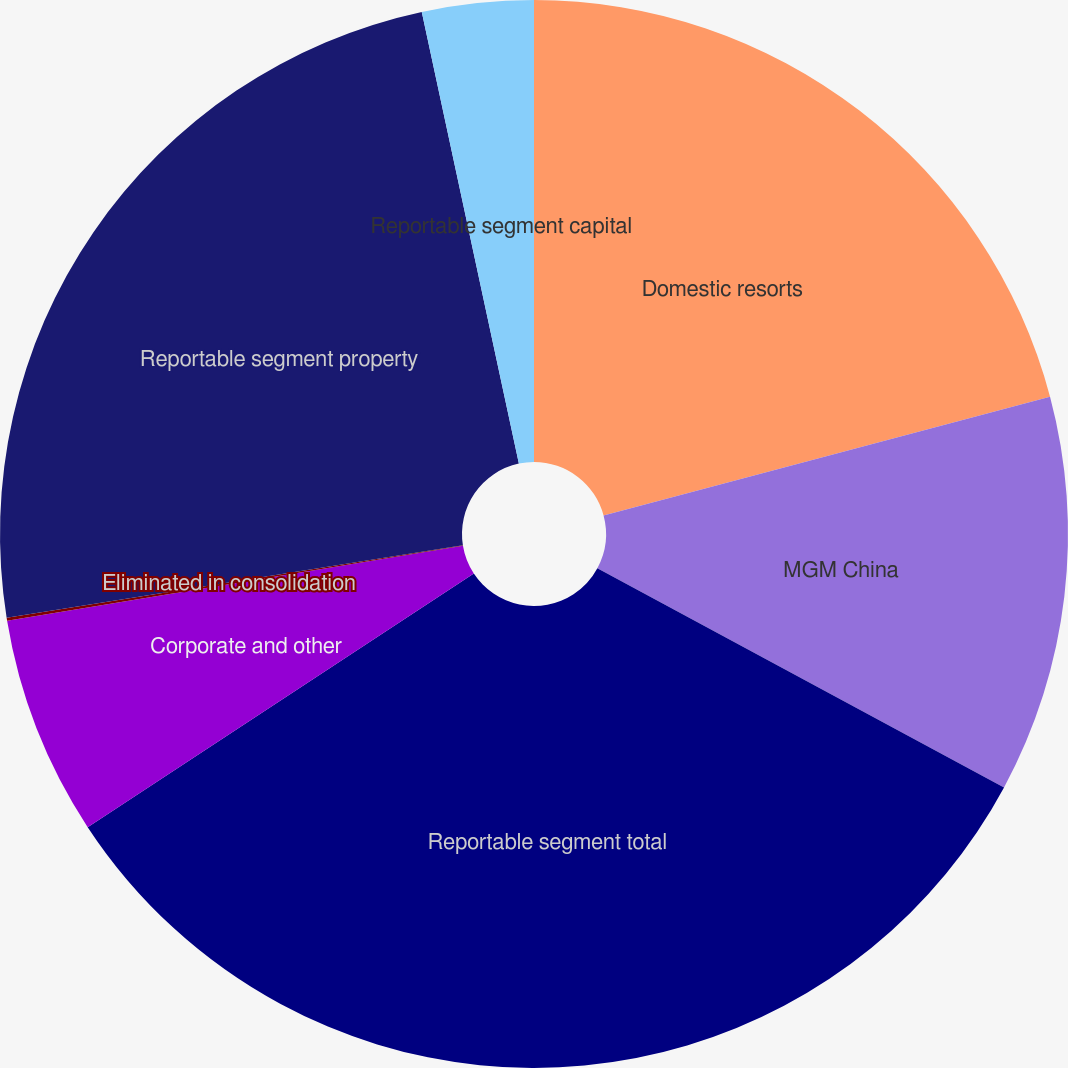Convert chart to OTSL. <chart><loc_0><loc_0><loc_500><loc_500><pie_chart><fcel>Domestic resorts<fcel>MGM China<fcel>Reportable segment total<fcel>Corporate and other<fcel>Eliminated in consolidation<fcel>Reportable segment property<fcel>Reportable segment capital<nl><fcel>20.86%<fcel>12.01%<fcel>32.88%<fcel>6.65%<fcel>0.09%<fcel>24.14%<fcel>3.37%<nl></chart> 